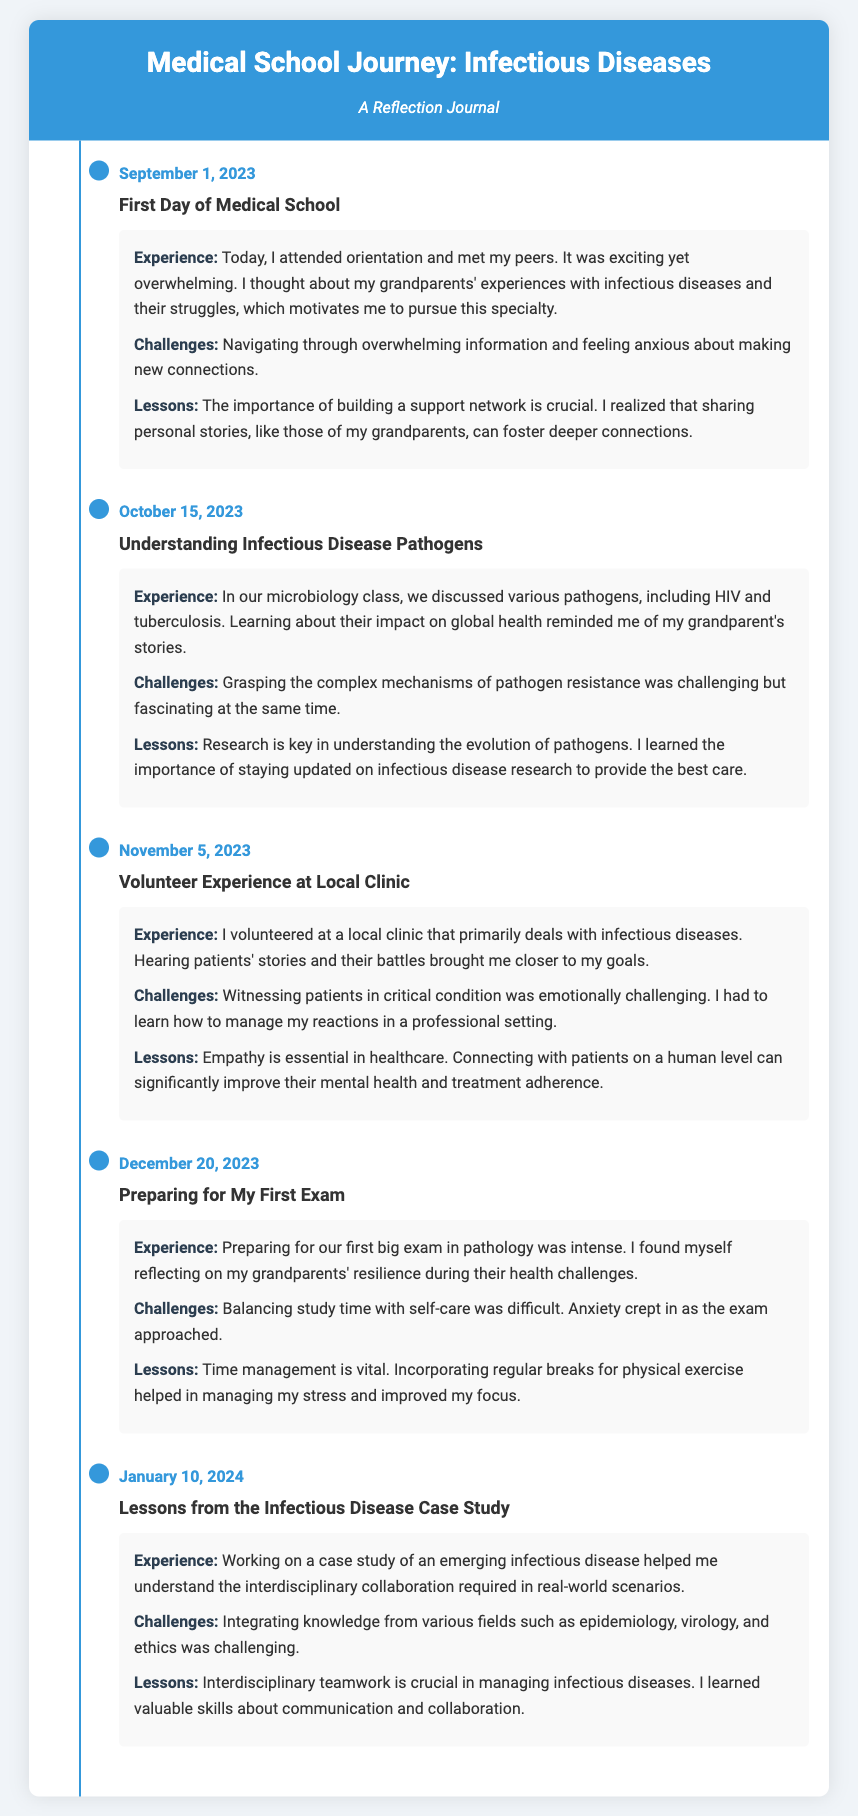What date did the first entry occur? The first entry date is explicitly stated in the document as September 1, 2023.
Answer: September 1, 2023 What was the title of the entry on October 15, 2023? The title for the entry on October 15, 2023, is listed in the document as "Understanding Infectious Disease Pathogens."
Answer: Understanding Infectious Disease Pathogens What was a major challenge faced on November 5, 2023? A significant challenge mentioned in the entry on November 5, 2023, is witnessing patients in critical condition.
Answer: Witnessing patients in critical condition What key lesson was learned from the case study on January 10, 2024? The key lesson learned from the case study is that interdisciplinary teamwork is crucial in managing infectious diseases.
Answer: Interdisciplinary teamwork is crucial What emotion did the author reflect on when preparing for the exam? The author reflected on anxiety as an emotion while preparing for the exam.
Answer: Anxiety How does the author connect their experiences in medical school to their grandparents? The author connects their experiences to their grandparents by reflecting on their stories and struggles with infectious diseases.
Answer: Their stories and struggles with infectious diseases Which pathogen was discussed in microbiology class on October 15, 2023? The document states that HIV and tuberculosis were discussed in microbiology class.
Answer: HIV and tuberculosis What is one method the author used to manage stress while studying? The author mentioned incorporating regular breaks for physical exercise as a method to manage stress.
Answer: Regular breaks for physical exercise 